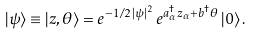Convert formula to latex. <formula><loc_0><loc_0><loc_500><loc_500>| \psi \rangle \equiv | z , \theta \rangle = e ^ { - 1 / 2 \, | \psi | ^ { 2 } } \, e ^ { a _ { \alpha } ^ { \dagger } z _ { \alpha } + b ^ { \dagger } \theta } \, | 0 \rangle \, .</formula> 